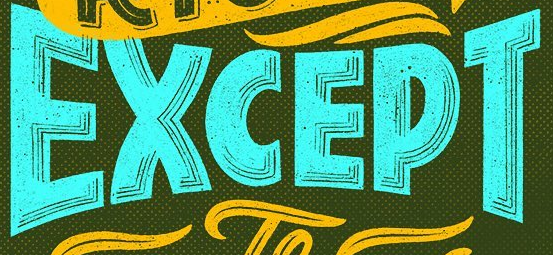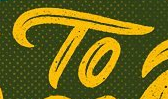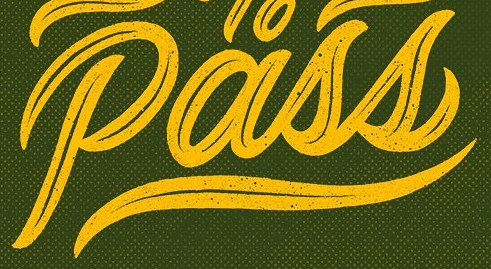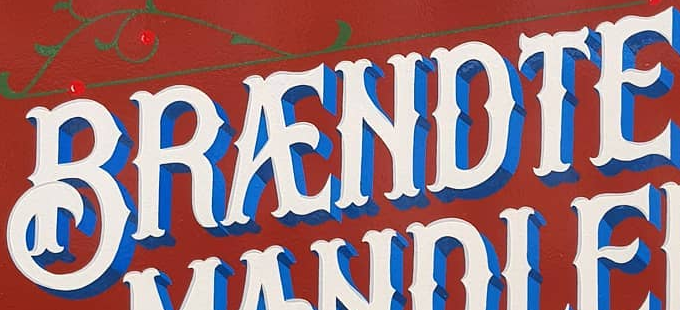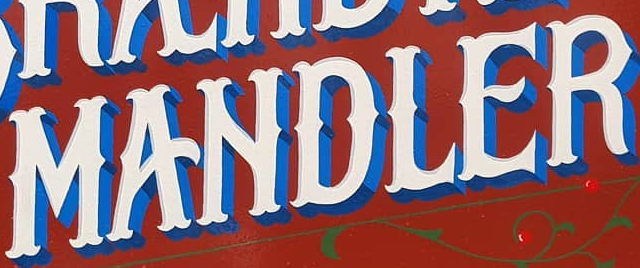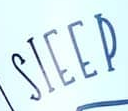Identify the words shown in these images in order, separated by a semicolon. EXCEPT; TO; Pass; BRÆNDTE; MANDLER; SIEEP 